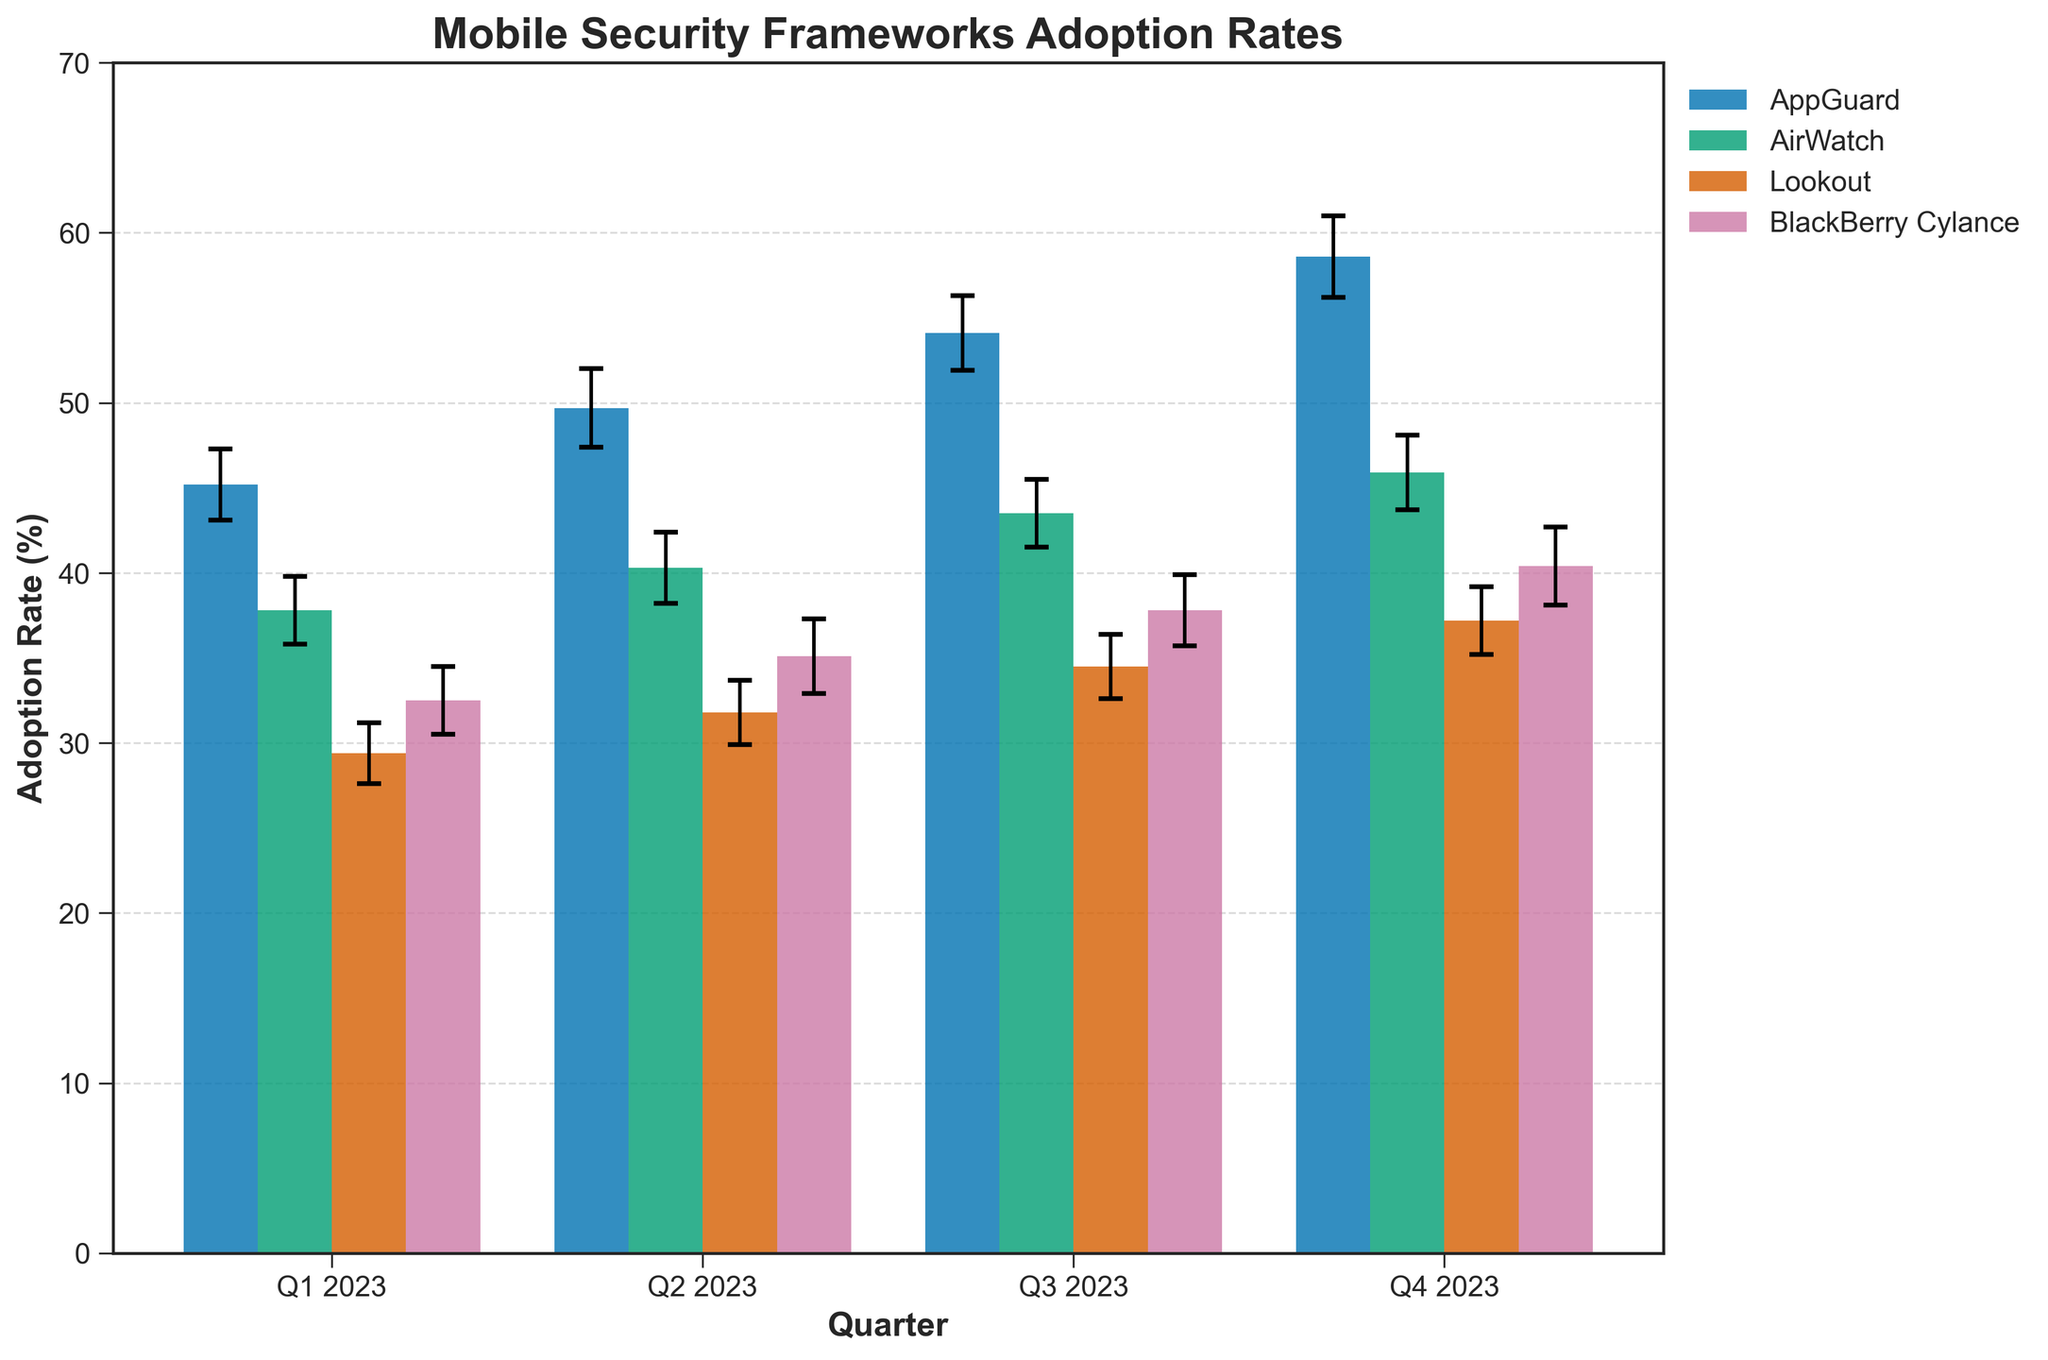What is the title of the figure? The title is displayed at the top of the figure. It helps in understanding the main subject of the plot.
Answer: Mobile Security Frameworks Adoption Rates What is the average adoption rate for AppGuard across all quarters? Sum up the adoption rates for AppGuard across Q1 to Q4, which are 45.2, 49.7, 54.1, and 58.6. Then, divide by the number of quarters (4). (45.2 + 49.7 + 54.1 + 58.6) / 4 = 207.6 / 4 = 51.9
Answer: 51.9% Which framework had the highest adoption rate in Q4 2023? Look at the adoption rates for each framework in Q4 2023. AppGuard: 58.6, AirWatch: 45.9, Lookout: 37.2, BlackBerry Cylance: 40.4. The highest value is 58.6 for AppGuard.
Answer: AppGuard How much did the adoption rate for BlackBerry Cylance change from Q1 to Q4 2023? Subtract the adoption rate in Q1 2023 from the adoption rate in Q4 2023 for BlackBerry Cylance: 40.4 - 32.5 = 7.9.
Answer: 7.9% Which quarter had the smallest adoption rate difference between AppGuard and AirWatch? Calculate the difference between AppGuard and AirWatch for each quarter. Q1: 45.2 - 37.8 = 7.4, Q2: 49.7 - 40.3 = 9.4, Q3: 54.1 - 43.5 = 10.6, Q4: 58.6 - 45.9 = 12.7. The smallest difference is in Q1.
Answer: Q1 2023 What is the maximum error margin displayed in the figure? Identify the highest error margin value among all frameworks and quarters. The values are 2.1, 2.3, 2.2, 2.4, 2.0, 2.1, 2.0, 2.2, 1.8, 1.9, 1.9, 2.0, 2.0, 2.2, 2.1, and 2.3. The highest value is 2.4.
Answer: 2.4 Which framework saw the most consistent growth in adoption rate in 2023? Determine the growth pattern by observing the adoption rates of each framework across quarters. AppGuard increased steadily from 45.2 to 58.6, AirWatch from 37.8 to 45.9, Lookout from 29.4 to 37.2, and BlackBerry Cylance from 32.5 to 40.4. AppGuard shows the most consistent increase.
Answer: AppGuard What is the total adoption rate for Lookout over all quarters combined? Add up the adoption rates for Lookout across Q1 to Q4: 29.4 + 31.8 + 34.5 + 37.2 = 132.9.
Answer: 132.9% In which quarter did AirWatch have the largest error margin? Compare the error margins for AirWatch across all quarters: Q1: 2.0, Q2: 2.1, Q3: 2.0, Q4: 2.2. The largest error margin is in Q4 with a value of 2.2.
Answer: Q4 2023 